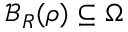Convert formula to latex. <formula><loc_0><loc_0><loc_500><loc_500>\mathcal { B } _ { R } ( { \boldsymbol \rho } ) \subseteq \Omega</formula> 